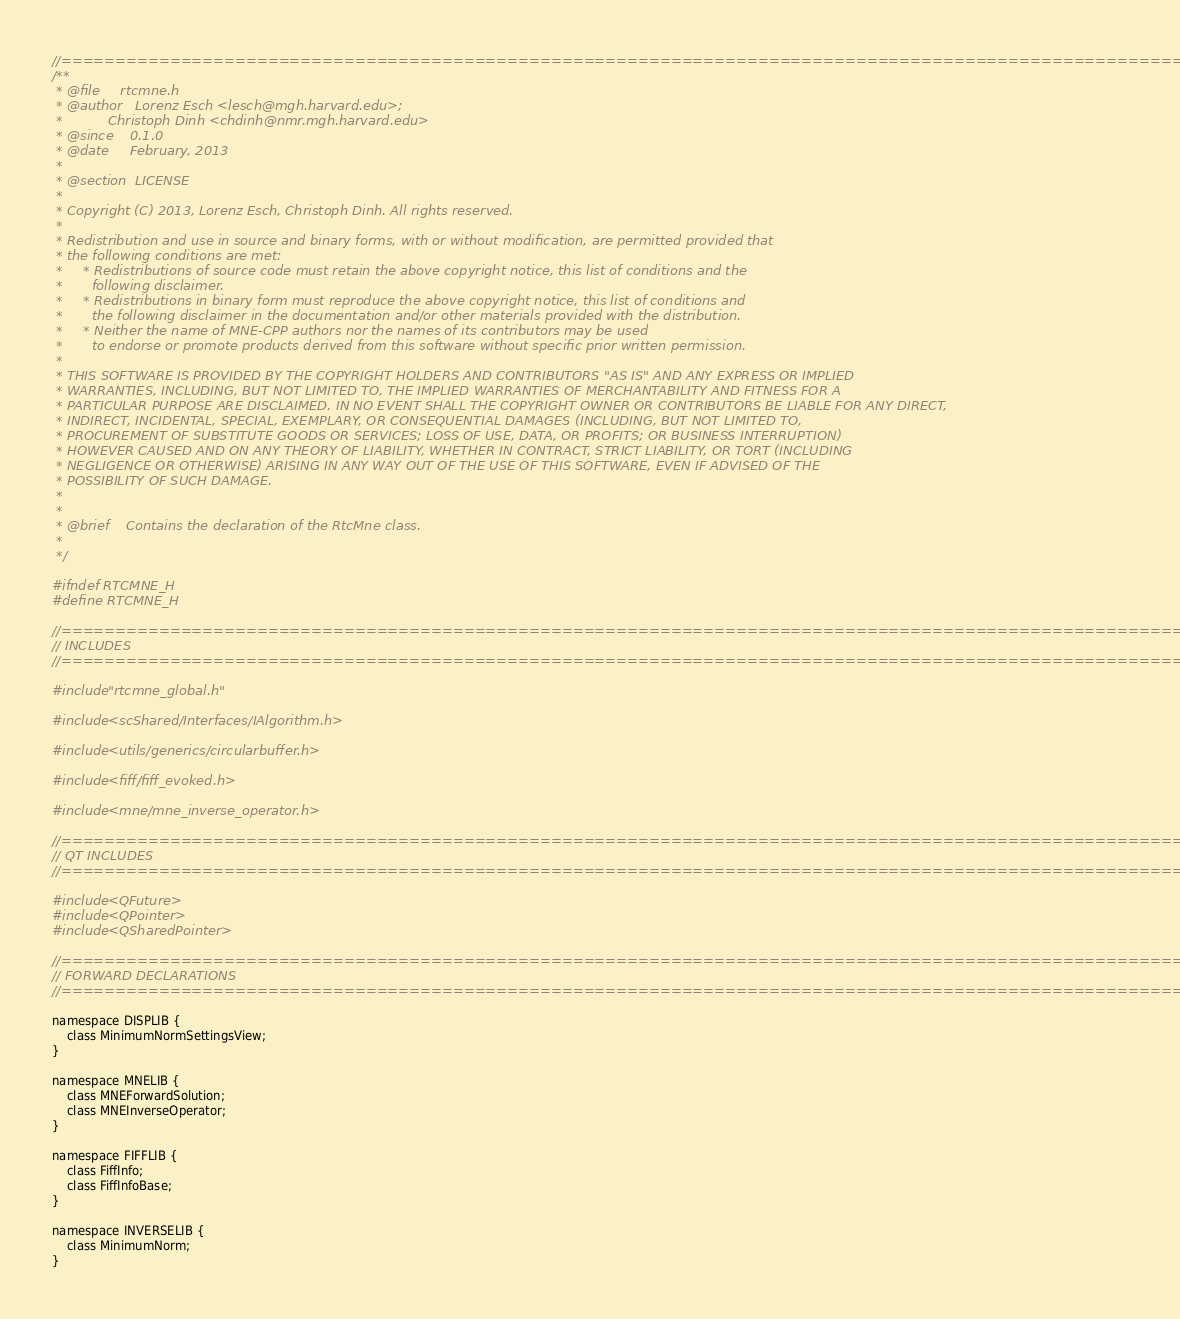Convert code to text. <code><loc_0><loc_0><loc_500><loc_500><_C_>//=============================================================================================================
/**
 * @file     rtcmne.h
 * @author   Lorenz Esch <lesch@mgh.harvard.edu>;
 *           Christoph Dinh <chdinh@nmr.mgh.harvard.edu>
 * @since    0.1.0
 * @date     February, 2013
 *
 * @section  LICENSE
 *
 * Copyright (C) 2013, Lorenz Esch, Christoph Dinh. All rights reserved.
 *
 * Redistribution and use in source and binary forms, with or without modification, are permitted provided that
 * the following conditions are met:
 *     * Redistributions of source code must retain the above copyright notice, this list of conditions and the
 *       following disclaimer.
 *     * Redistributions in binary form must reproduce the above copyright notice, this list of conditions and
 *       the following disclaimer in the documentation and/or other materials provided with the distribution.
 *     * Neither the name of MNE-CPP authors nor the names of its contributors may be used
 *       to endorse or promote products derived from this software without specific prior written permission.
 *
 * THIS SOFTWARE IS PROVIDED BY THE COPYRIGHT HOLDERS AND CONTRIBUTORS "AS IS" AND ANY EXPRESS OR IMPLIED
 * WARRANTIES, INCLUDING, BUT NOT LIMITED TO, THE IMPLIED WARRANTIES OF MERCHANTABILITY AND FITNESS FOR A
 * PARTICULAR PURPOSE ARE DISCLAIMED. IN NO EVENT SHALL THE COPYRIGHT OWNER OR CONTRIBUTORS BE LIABLE FOR ANY DIRECT,
 * INDIRECT, INCIDENTAL, SPECIAL, EXEMPLARY, OR CONSEQUENTIAL DAMAGES (INCLUDING, BUT NOT LIMITED TO,
 * PROCUREMENT OF SUBSTITUTE GOODS OR SERVICES; LOSS OF USE, DATA, OR PROFITS; OR BUSINESS INTERRUPTION)
 * HOWEVER CAUSED AND ON ANY THEORY OF LIABILITY, WHETHER IN CONTRACT, STRICT LIABILITY, OR TORT (INCLUDING
 * NEGLIGENCE OR OTHERWISE) ARISING IN ANY WAY OUT OF THE USE OF THIS SOFTWARE, EVEN IF ADVISED OF THE
 * POSSIBILITY OF SUCH DAMAGE.
 *
 *
 * @brief    Contains the declaration of the RtcMne class.
 *
 */

#ifndef RTCMNE_H
#define RTCMNE_H

//=============================================================================================================
// INCLUDES
//=============================================================================================================

#include "rtcmne_global.h"

#include <scShared/Interfaces/IAlgorithm.h>

#include <utils/generics/circularbuffer.h>

#include <fiff/fiff_evoked.h>

#include <mne/mne_inverse_operator.h>

//=============================================================================================================
// QT INCLUDES
//=============================================================================================================

#include <QFuture>
#include <QPointer>
#include <QSharedPointer>

//=============================================================================================================
// FORWARD DECLARATIONS
//=============================================================================================================

namespace DISPLIB {
    class MinimumNormSettingsView;
}

namespace MNELIB {
    class MNEForwardSolution;
    class MNEInverseOperator;
}

namespace FIFFLIB {
    class FiffInfo;
    class FiffInfoBase;
}

namespace INVERSELIB {
    class MinimumNorm;
}
</code> 